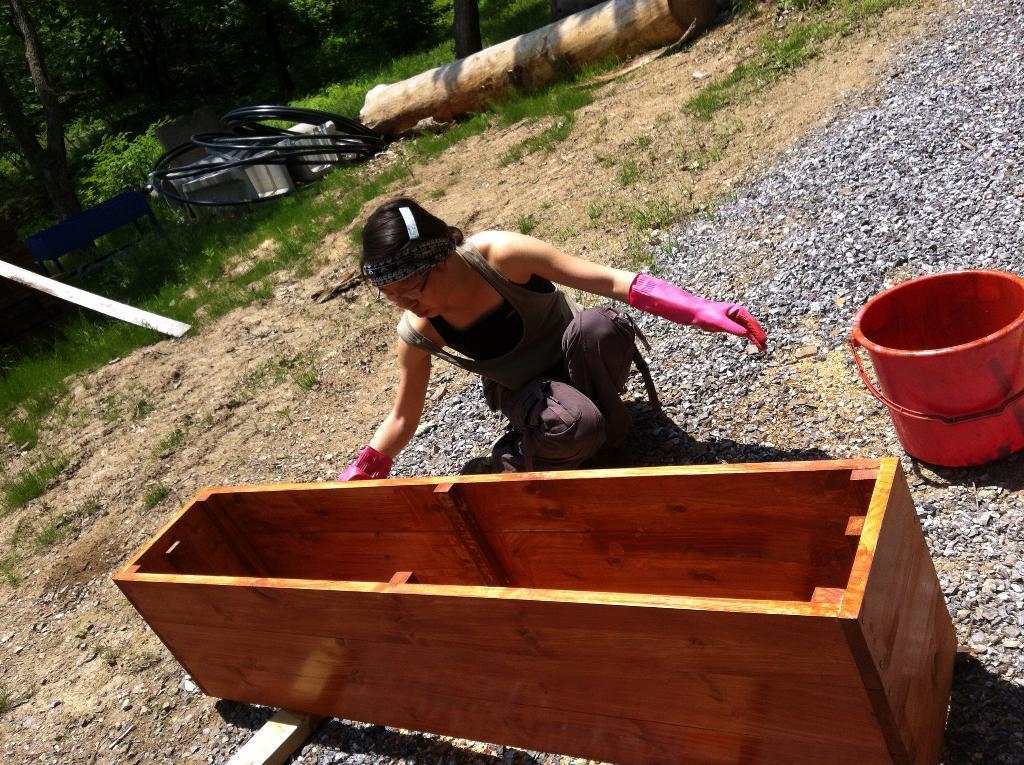Can you describe this image briefly? In the center of the image we can see person sitting on the ground. On the right side of the image we can see bucket and stones. On the left side of the image we can see wires and bench. In the background we can see trees and grass. 